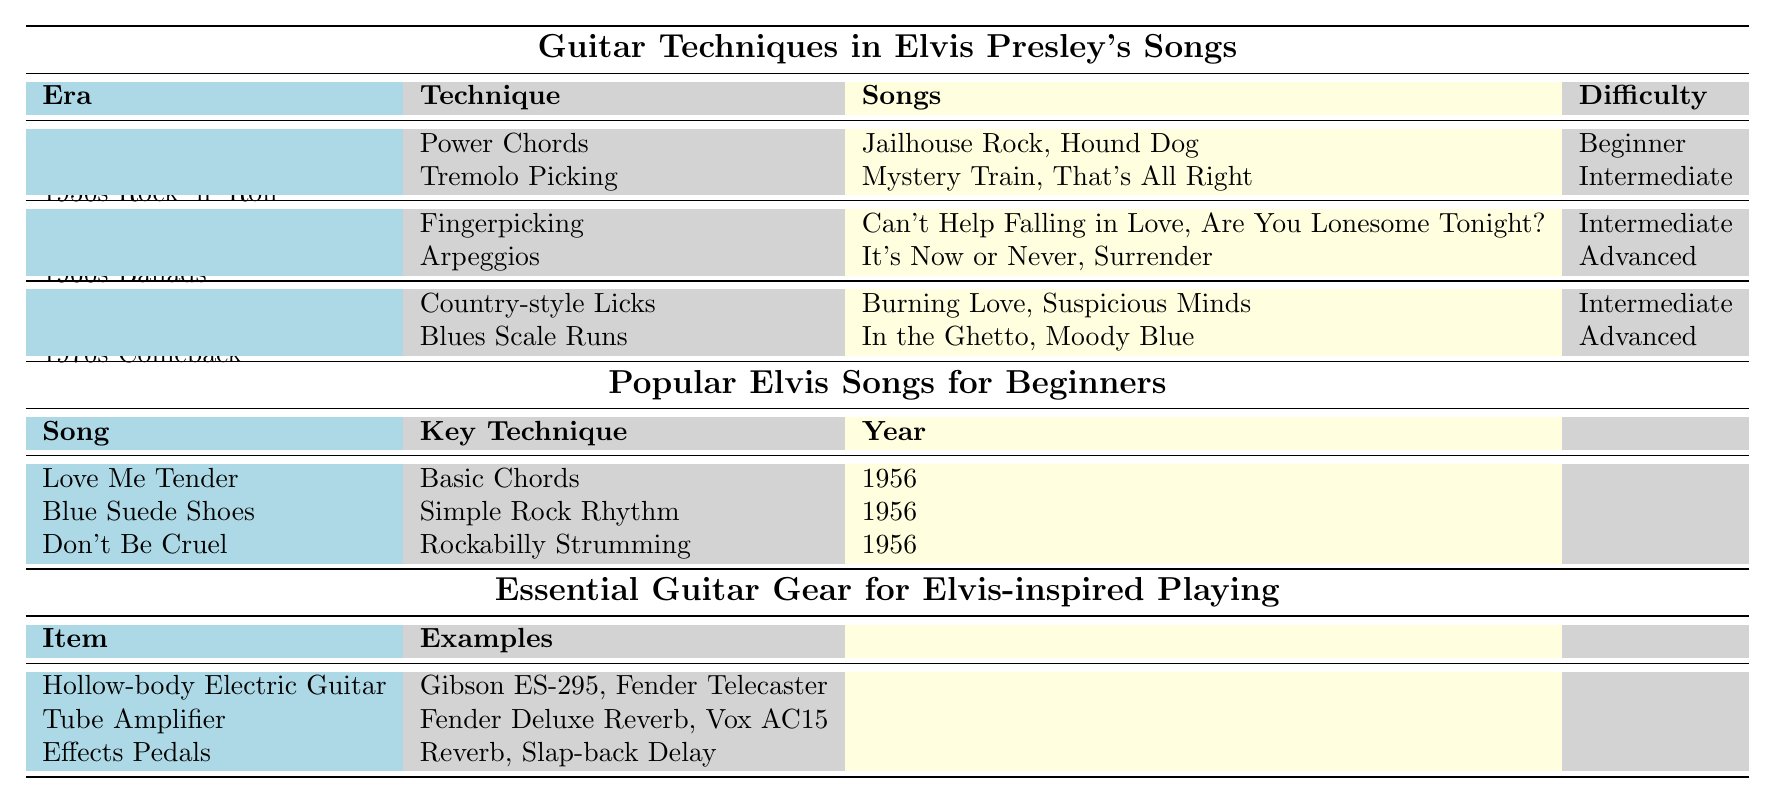What techniques are associated with 1960s Ballads? The table lists two techniques under the 1960s Ballads era: Fingerpicking and Arpeggios.
Answer: Fingerpicking and Arpeggios Which song features Power Chords? Looking at the table, "Jailhouse Rock" and "Hound Dog" are both songs that feature Power Chords under the 1950s Rock 'n' Roll techniques.
Answer: Jailhouse Rock, Hound Dog What is the difficulty level of Blues Scale Runs? The table indicates that Blues Scale Runs are classified as an Advanced technique.
Answer: Advanced How many techniques are categorized as Intermediate? From the table, there are four techniques marked as Intermediate: Tremolo Picking, Fingerpicking, Country-style Licks, and each counts as one, totaling four techniques.
Answer: 4 Is "It's Now or Never" associated with Basic Chords? The table lists "It's Now or Never" under the Arpeggios technique in the 1960s Ballads era, not Basic Chords.
Answer: No Which era uses Tremolo Picking? Tremolo Picking is used in the 1950s Rock 'n' Roll era as per the table's details.
Answer: 1950s Rock 'n' Roll List all the songs associated with Intermediate techniques. The table shows the songs associated with Intermediate techniques are: "Mystery Train," "That's All Right," "Can't Help Falling in Love," "Are You Lonesome Tonight?" and "Burning Love."
Answer: Mystery Train, That's All Right, Can't Help Falling in Love, Are You Lonesome Tonight?, Burning Love What percentage of guitar techniques in Elvis's songs are classified as Advanced? There are a total of 6 techniques in the table: 2 Advanced techniques out of 6 makes the percentage (2/6) * 100 = 33.33%.
Answer: 33.33% How many songs are linked to the technique of Fingerpicking? Fingerpicking is linked to 2 songs: "Can't Help Falling in Love" and "Are You Lonesome Tonight?"
Answer: 2 songs Which guitar gear item has examples listed as Fender Deluxe Reverb and Vox AC15? The item listed under the Essential Guitar Gear section with those examples is Tube Amplifier.
Answer: Tube Amplifier 